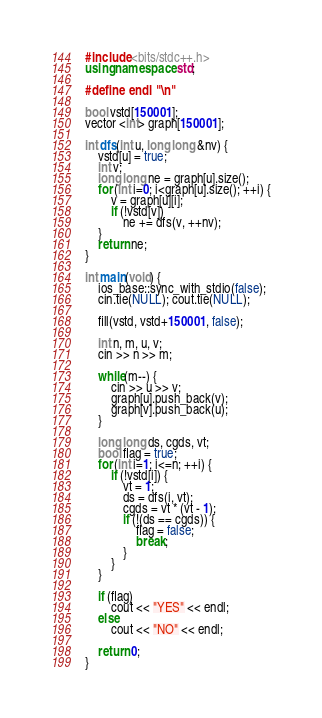Convert code to text. <code><loc_0><loc_0><loc_500><loc_500><_C++_>#include <bits/stdc++.h>
using namespace std;

#define endl "\n"

bool vstd[150001];
vector <int> graph[150001];

int dfs(int u, long long &nv) {
    vstd[u] = true;
    int v;
    long long ne = graph[u].size();
    for (int i=0; i<graph[u].size(); ++i) {
        v = graph[u][i];
        if (!vstd[v])
            ne += dfs(v, ++nv);
    }
    return ne;
}

int main(void) {
    ios_base::sync_with_stdio(false); 
    cin.tie(NULL); cout.tie(NULL);

    fill(vstd, vstd+150001, false);

    int n, m, u, v;
    cin >> n >> m;

    while(m--) {
        cin >> u >> v;
        graph[u].push_back(v);
        graph[v].push_back(u);
    }

    long long ds, cgds, vt;
    bool flag = true;
    for (int i=1; i<=n; ++i) {
        if (!vstd[i]) {
            vt = 1;
            ds = dfs(i, vt);
            cgds = vt * (vt - 1);
            if (!(ds == cgds)) {
                flag = false;
                break;
            }
        }
    }

    if (flag)
        cout << "YES" << endl;
    else
        cout << "NO" << endl;

    return 0;
}
</code> 